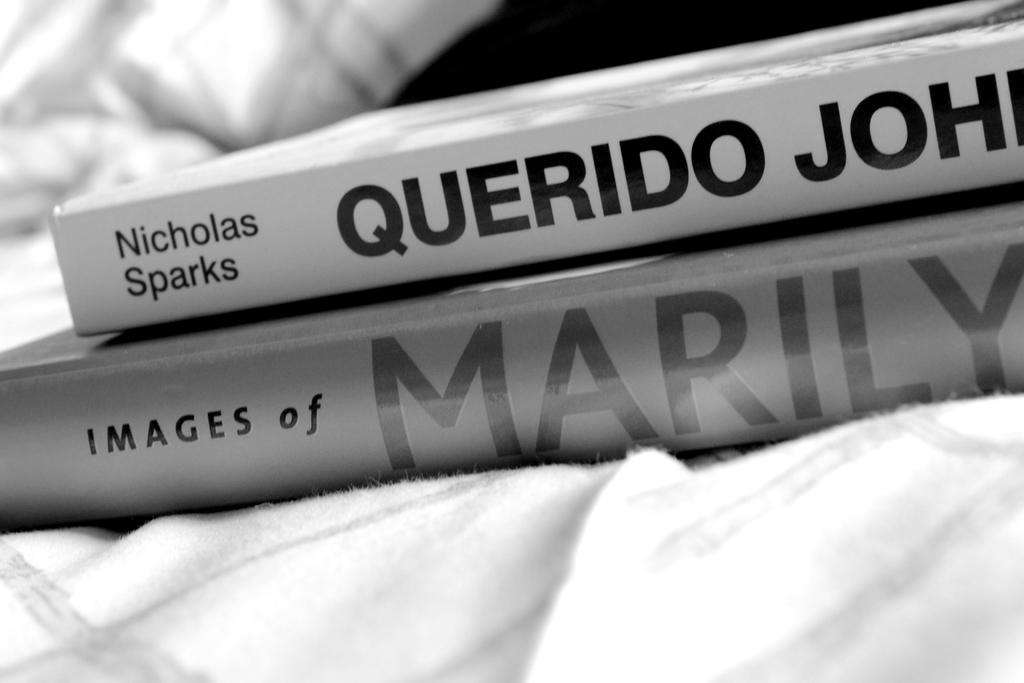<image>
Write a terse but informative summary of the picture. Two books pictured, the first is by Nicholas Sparks. 